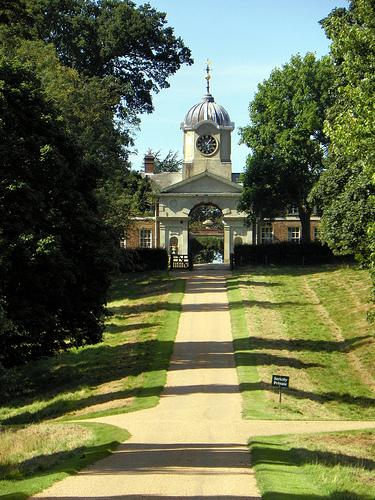Question: when is it?
Choices:
A. Yesterday.
B. Day time.
C. Tomorrow.
D. Night.
Answer with the letter. Answer: B Question: what is on the building?
Choices:
A. Awning.
B. Sign.
C. A clock.
D. Lettering.
Answer with the letter. Answer: C Question: where is the house?
Choices:
A. Near the park.
B. Near the school.
C. At the end of the road.
D. Near the store.
Answer with the letter. Answer: C 